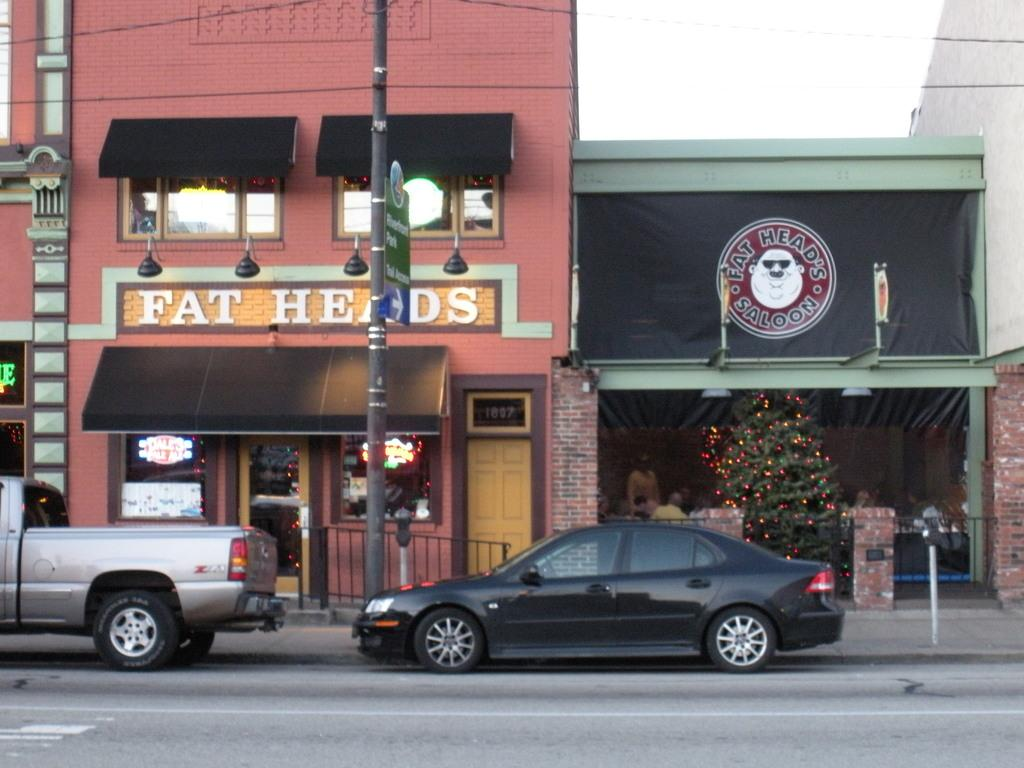Provide a one-sentence caption for the provided image. The Fat Head's Saloon has a Christmas tree inside. 